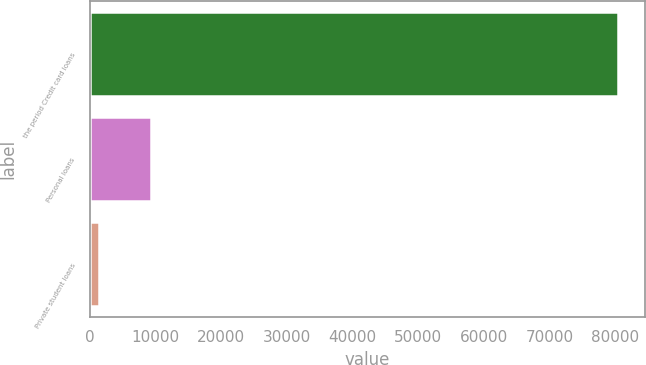Convert chart to OTSL. <chart><loc_0><loc_0><loc_500><loc_500><bar_chart><fcel>the period Credit card loans<fcel>Personal loans<fcel>Private student loans<nl><fcel>80484<fcel>9356.1<fcel>1453<nl></chart> 